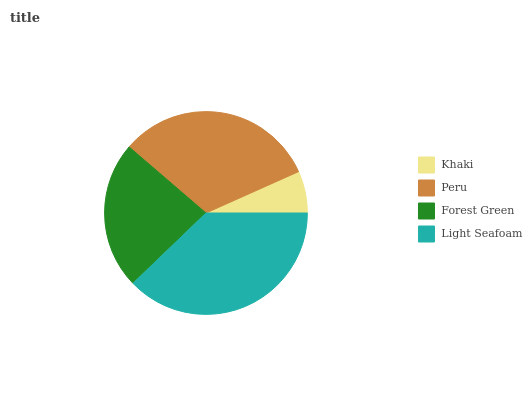Is Khaki the minimum?
Answer yes or no. Yes. Is Light Seafoam the maximum?
Answer yes or no. Yes. Is Peru the minimum?
Answer yes or no. No. Is Peru the maximum?
Answer yes or no. No. Is Peru greater than Khaki?
Answer yes or no. Yes. Is Khaki less than Peru?
Answer yes or no. Yes. Is Khaki greater than Peru?
Answer yes or no. No. Is Peru less than Khaki?
Answer yes or no. No. Is Peru the high median?
Answer yes or no. Yes. Is Forest Green the low median?
Answer yes or no. Yes. Is Light Seafoam the high median?
Answer yes or no. No. Is Peru the low median?
Answer yes or no. No. 